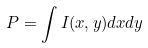Convert formula to latex. <formula><loc_0><loc_0><loc_500><loc_500>P = \int I ( x , y ) d x d y</formula> 